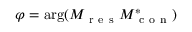Convert formula to latex. <formula><loc_0><loc_0><loc_500><loc_500>\varphi = \arg ( M _ { r e s } M _ { c o n } ^ { * } )</formula> 